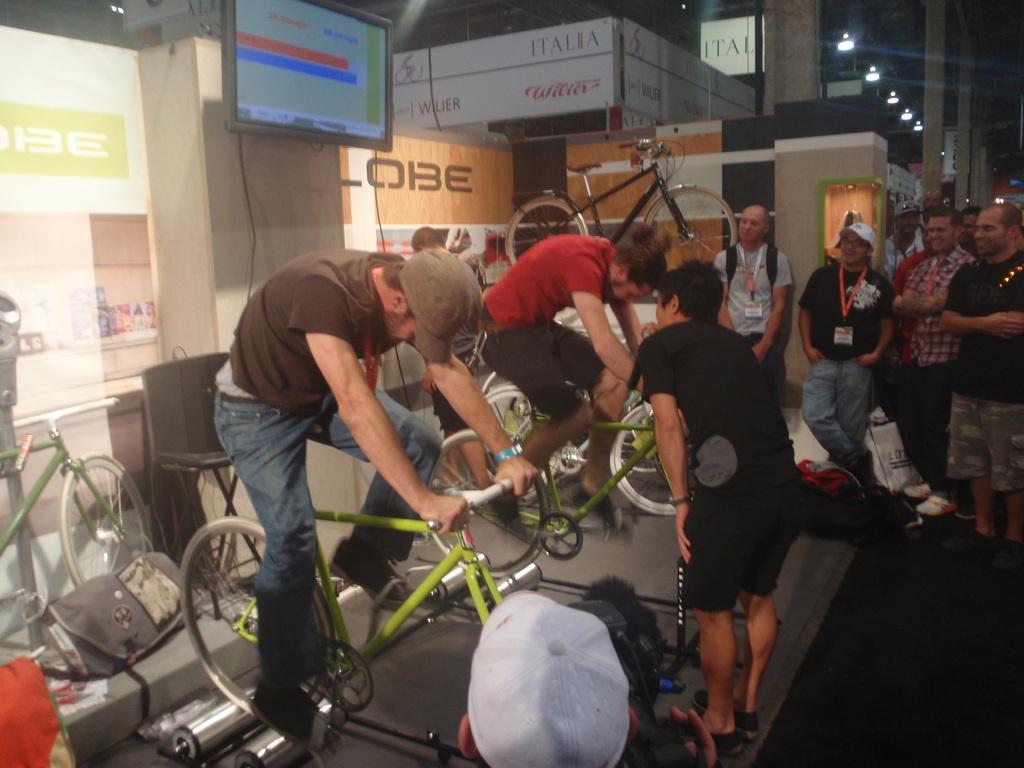In one or two sentences, can you explain what this image depicts? In the image it seems like there is a cycling competition between the two men. There are crowd who are watching the two men who are cycling. At the background there is a led tv,wall and big hoarding. To the left side there is a cycle and a bag beside it. 